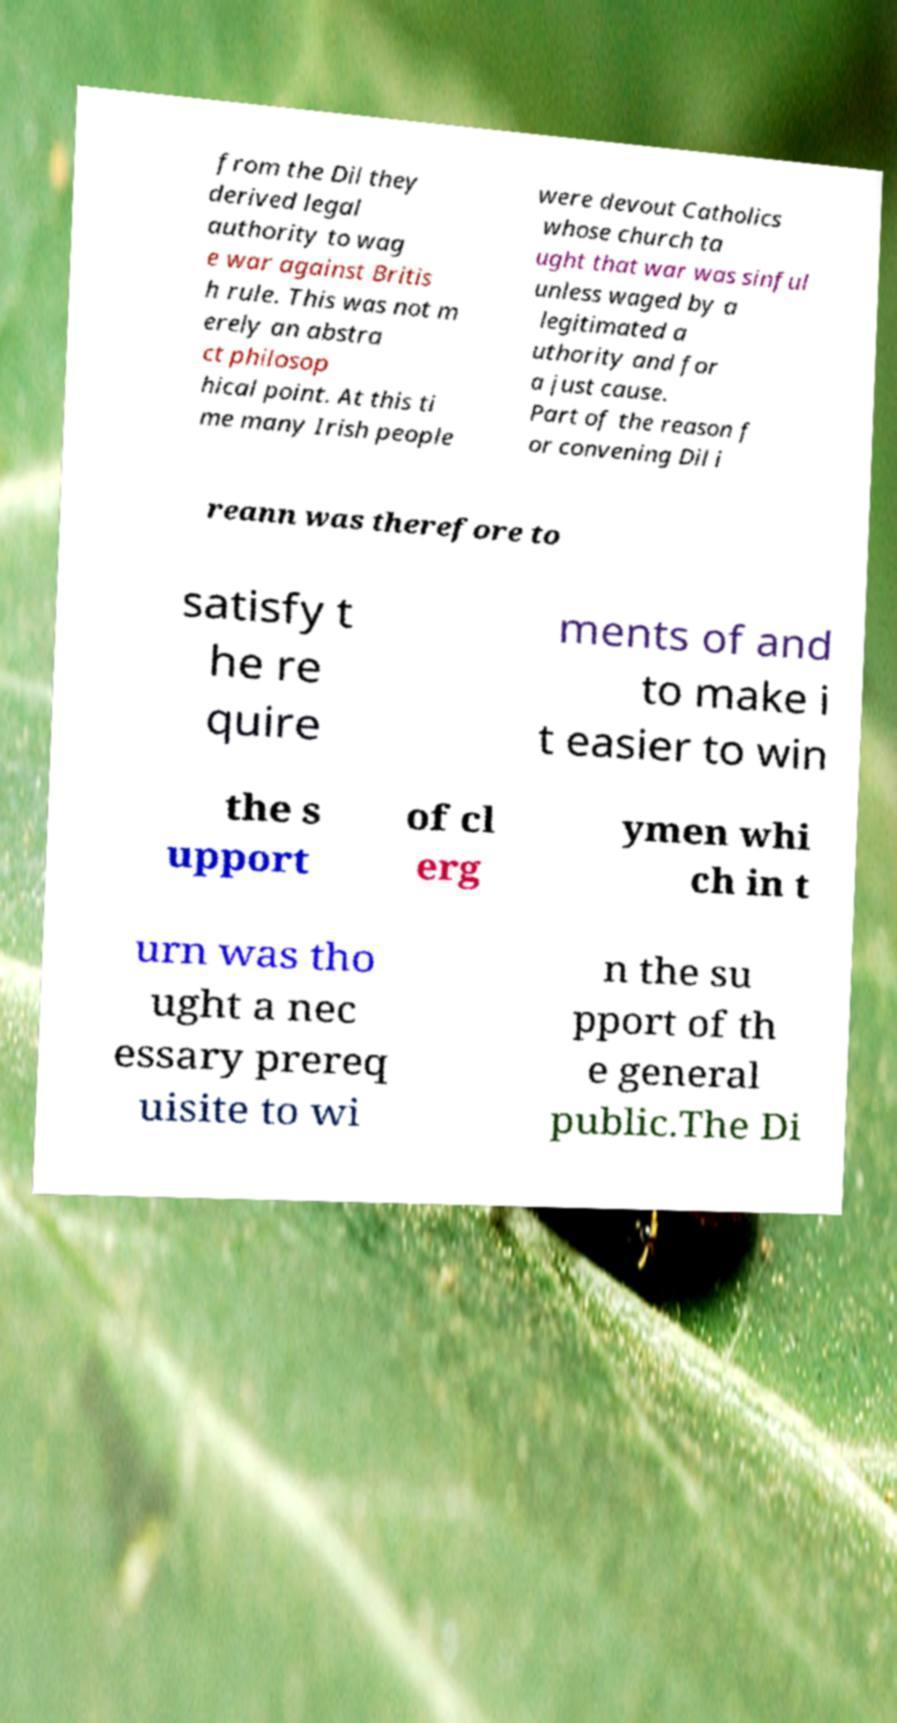I need the written content from this picture converted into text. Can you do that? from the Dil they derived legal authority to wag e war against Britis h rule. This was not m erely an abstra ct philosop hical point. At this ti me many Irish people were devout Catholics whose church ta ught that war was sinful unless waged by a legitimated a uthority and for a just cause. Part of the reason f or convening Dil i reann was therefore to satisfy t he re quire ments of and to make i t easier to win the s upport of cl erg ymen whi ch in t urn was tho ught a nec essary prereq uisite to wi n the su pport of th e general public.The Di 